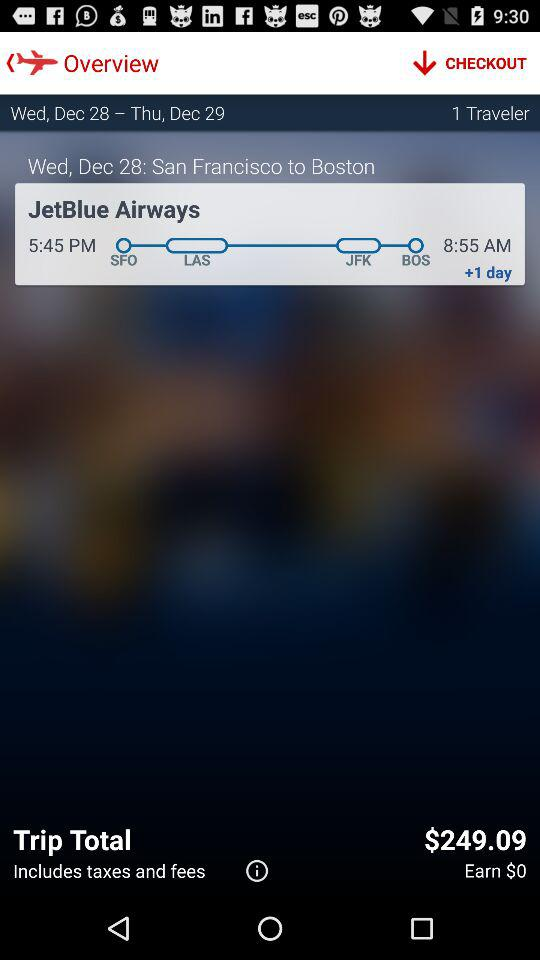How many travelers are there? There is 1 traveler. 